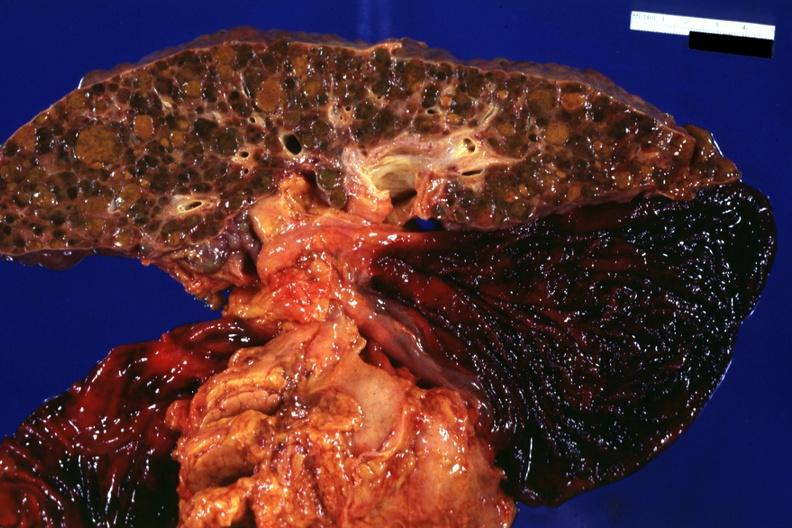s hemangioma present?
Answer the question using a single word or phrase. No 